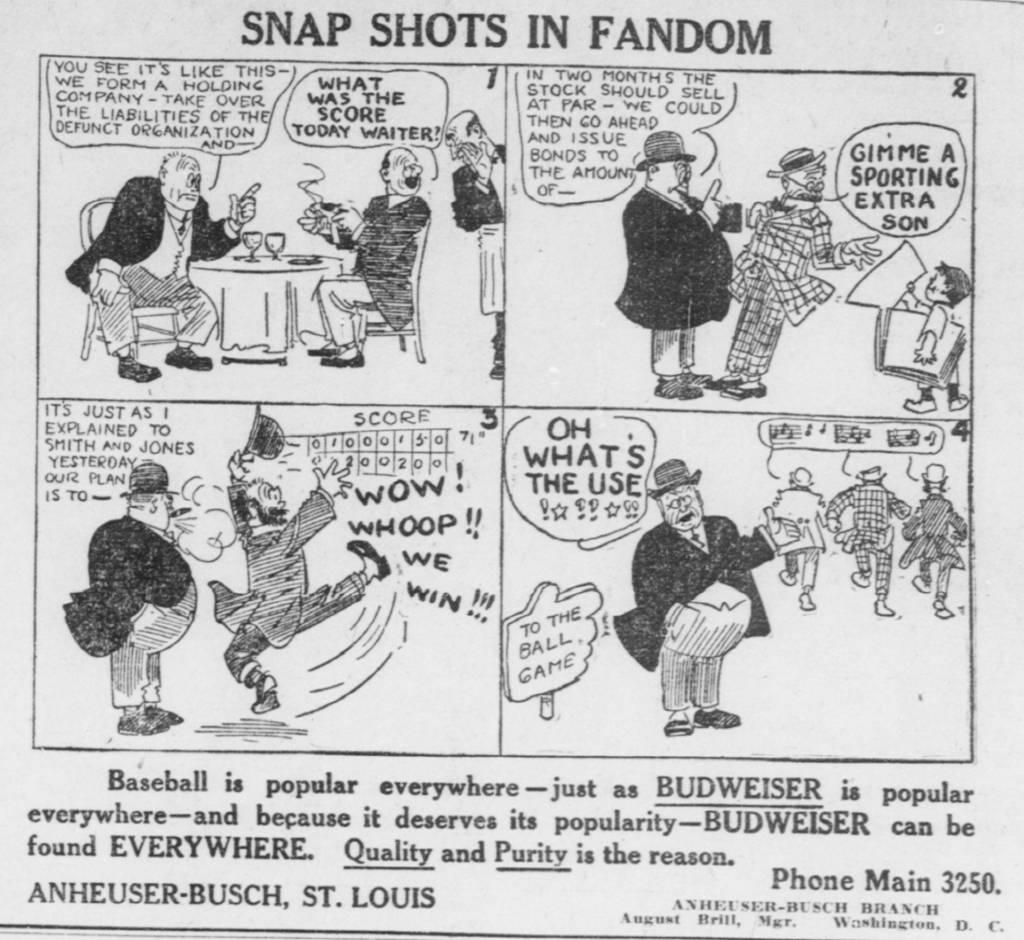What type of picture is in the image? There is a comic picture in the image. What can be found within the comic picture? There is text and images in the comic picture. What type of jeans is the character wearing in the comic picture? There is no character wearing jeans in the comic picture, as it only contains text and images. Is there a veil visible in the comic picture? There is no veil present in the comic picture; it only contains text and images. 